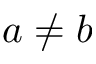Convert formula to latex. <formula><loc_0><loc_0><loc_500><loc_500>a \neq b</formula> 